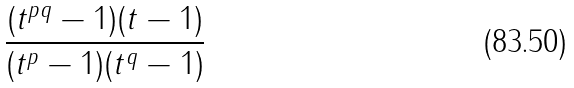<formula> <loc_0><loc_0><loc_500><loc_500>\frac { ( t ^ { p q } - 1 ) ( t - 1 ) } { ( t ^ { p } - 1 ) ( t ^ { q } - 1 ) }</formula> 